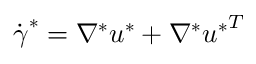<formula> <loc_0><loc_0><loc_500><loc_500>\dot { \gamma } ^ { * } = \nabla ^ { * } u ^ { * } + \nabla ^ { * } { u ^ { * } } ^ { T }</formula> 